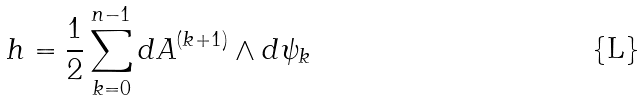Convert formula to latex. <formula><loc_0><loc_0><loc_500><loc_500>h = \frac { 1 } { 2 } \sum _ { k = 0 } ^ { n - 1 } d A ^ { ( k + 1 ) } \wedge d \psi _ { k }</formula> 